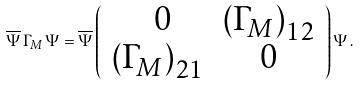<formula> <loc_0><loc_0><loc_500><loc_500>\overline { \Psi } \, { \Gamma } _ { M } \, { \Psi } = \overline { \Psi } \left ( \begin{array} { c c } { \ 0 } & { { \left ( { \Gamma _ { M } } \right ) _ { 1 2 } } } \\ { { \left ( { \Gamma _ { M } } \right ) _ { 2 1 } } } & { 0 } \end{array} \right ) { \Psi } \, .</formula> 